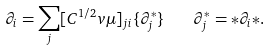<formula> <loc_0><loc_0><loc_500><loc_500>\partial _ { i } = \sum _ { j } [ C ^ { 1 / 2 } _ { \ } v \mu ] _ { j i } \{ \partial ^ { * } _ { j } \} \quad \partial _ { j } ^ { * } = * \partial _ { i } { * } .</formula> 